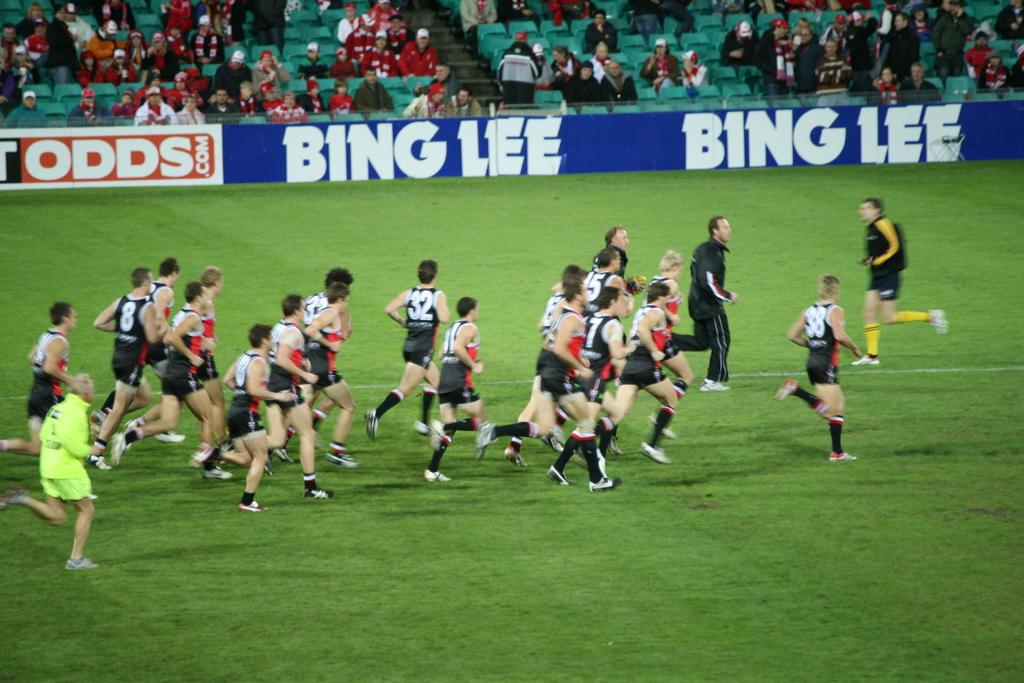How many people are in the image? There are persons in the image. What are the persons wearing? The persons are wearing clothes. What activity are the persons in the image engaged in? The persons are running in a stadium. a stadium. Are there any other people visible in the image? Yes, there are persons at the top of the image. What are the persons at the top of the image doing? The persons at the top are sitting on chairs. What type of harmony is being played by the baseball in the image? There is no baseball present in the image, and therefore no harmony can be played. 